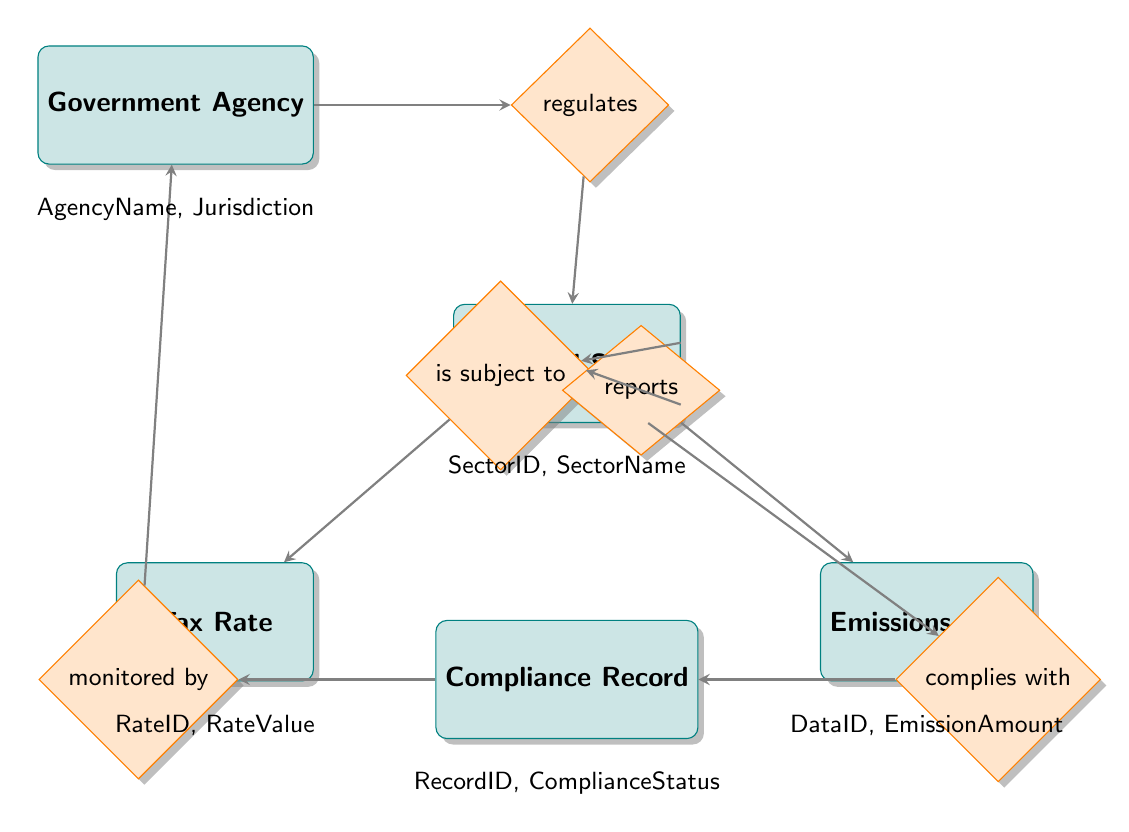What is the main entity that regulates the Industrial Sector? The diagram shows a direct relationship from the Government Agency to the Industrial Sector through the "regulates" relationship. Therefore, the Government Agency is responsible for this regulation.
Answer: Government Agency How many primary entities are represented in the diagram? Analyzing the diagram, we can count five primary entities: Government Agency, Industrial Sector, Tax Rate, Emissions Data, and Compliance Record.
Answer: 5 Which entity reports emissions data? The relationship labeled "reports" connects the Industrial Sector to Emissions Data. This indicates that the Industrial Sector is responsible for reporting emissions data.
Answer: Industrial Sector What type of relationship exists between Industrial Sector and Tax Rate? The relationship labeled "is subject to" indicates that the Industrial Sector is associated with Tax Rate, showing it is subject to this tax.
Answer: is subject to Which entity monitors the Compliance Record? The diagram contains a relationship labeled "monitored by," which connects the Compliance Record back to the Government Agency, indicating that it is the entity responsible for monitoring compliance.
Answer: Government Agency How is Compliance Record linked to Industrial Sector? The diagram shows a "complies with" relationship between the Compliance Record and the Industrial Sector, which shows that compliance records are associated with specific industrial sectors regarding regulations.
Answer: complies with What key attribute does the Government Agency entity possess? According to the diagram, one of the key attributes listed for the Government Agency is "AgencyName," indicating its identity and designation.
Answer: AgencyName What is the nature of the relationship between Tax Rate and Industrial Sector? The relationship labeled "applies to" connects Tax Rate to Industrial Sector, signifying that specific tax rates are applied to different industrial sectors based on regulation.
Answer: applies to 